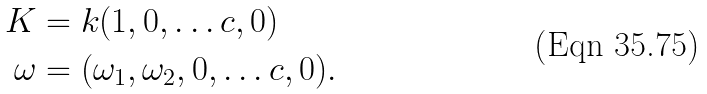<formula> <loc_0><loc_0><loc_500><loc_500>K & = k ( 1 , 0 , \dots c , 0 ) \\ \omega & = ( \omega _ { 1 } , \omega _ { 2 } , 0 , \dots c , 0 ) .</formula> 